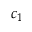Convert formula to latex. <formula><loc_0><loc_0><loc_500><loc_500>c _ { 1 }</formula> 